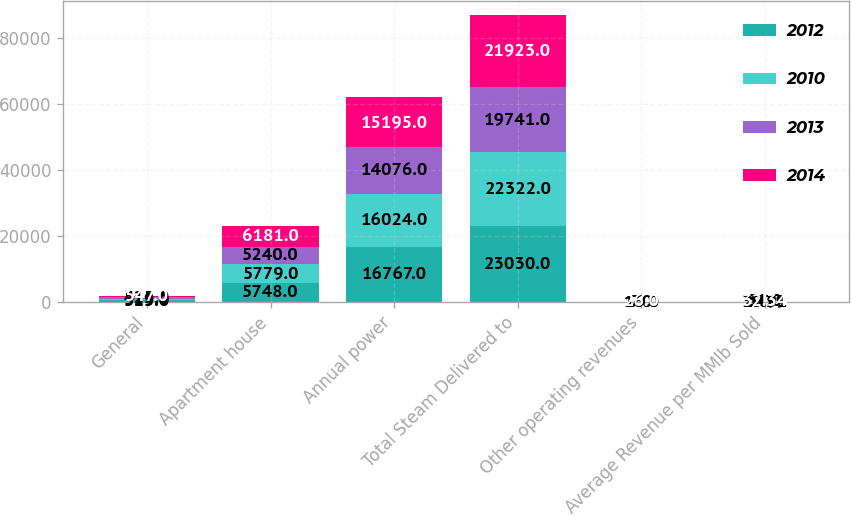Convert chart to OTSL. <chart><loc_0><loc_0><loc_500><loc_500><stacked_bar_chart><ecel><fcel>General<fcel>Apartment house<fcel>Annual power<fcel>Total Steam Delivered to<fcel>Other operating revenues<fcel>Average Revenue per MMlb Sold<nl><fcel>2012<fcel>515<fcel>5748<fcel>16767<fcel>23030<fcel>16<fcel>27.79<nl><fcel>2010<fcel>519<fcel>5779<fcel>16024<fcel>22322<fcel>7<fcel>30.91<nl><fcel>2013<fcel>425<fcel>5240<fcel>14076<fcel>19741<fcel>16<fcel>31<nl><fcel>2014<fcel>547<fcel>6181<fcel>15195<fcel>21923<fcel>26<fcel>32.34<nl></chart> 